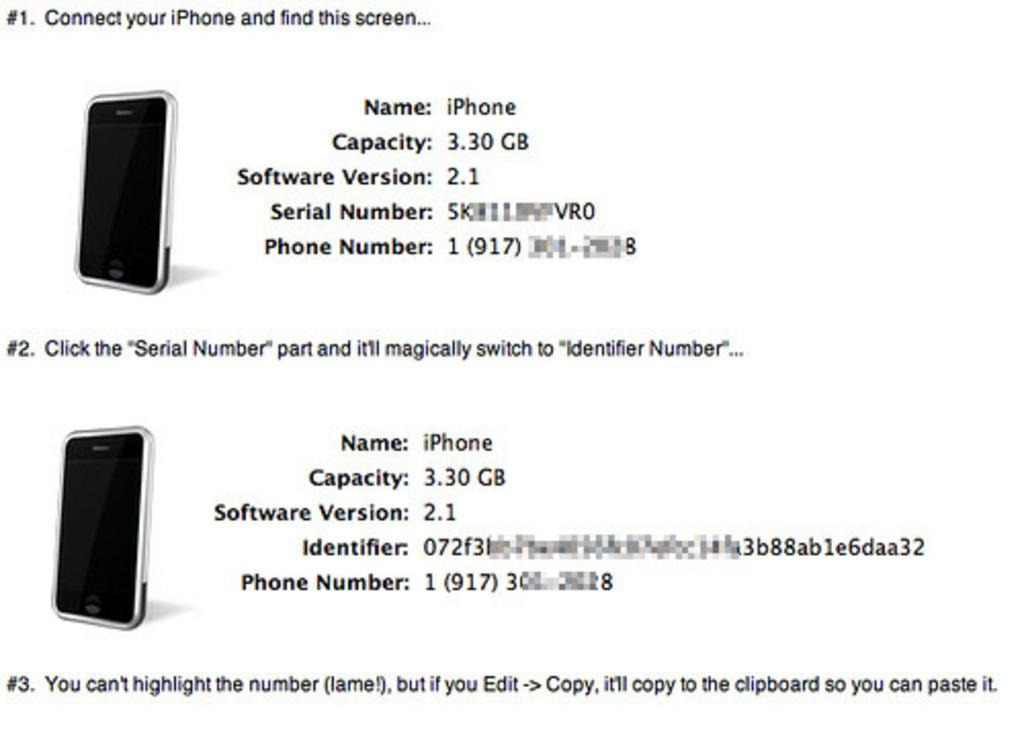<image>
Offer a succinct explanation of the picture presented. Directions on how to locate your iPhone identifier number and copy it are written on this paper. 